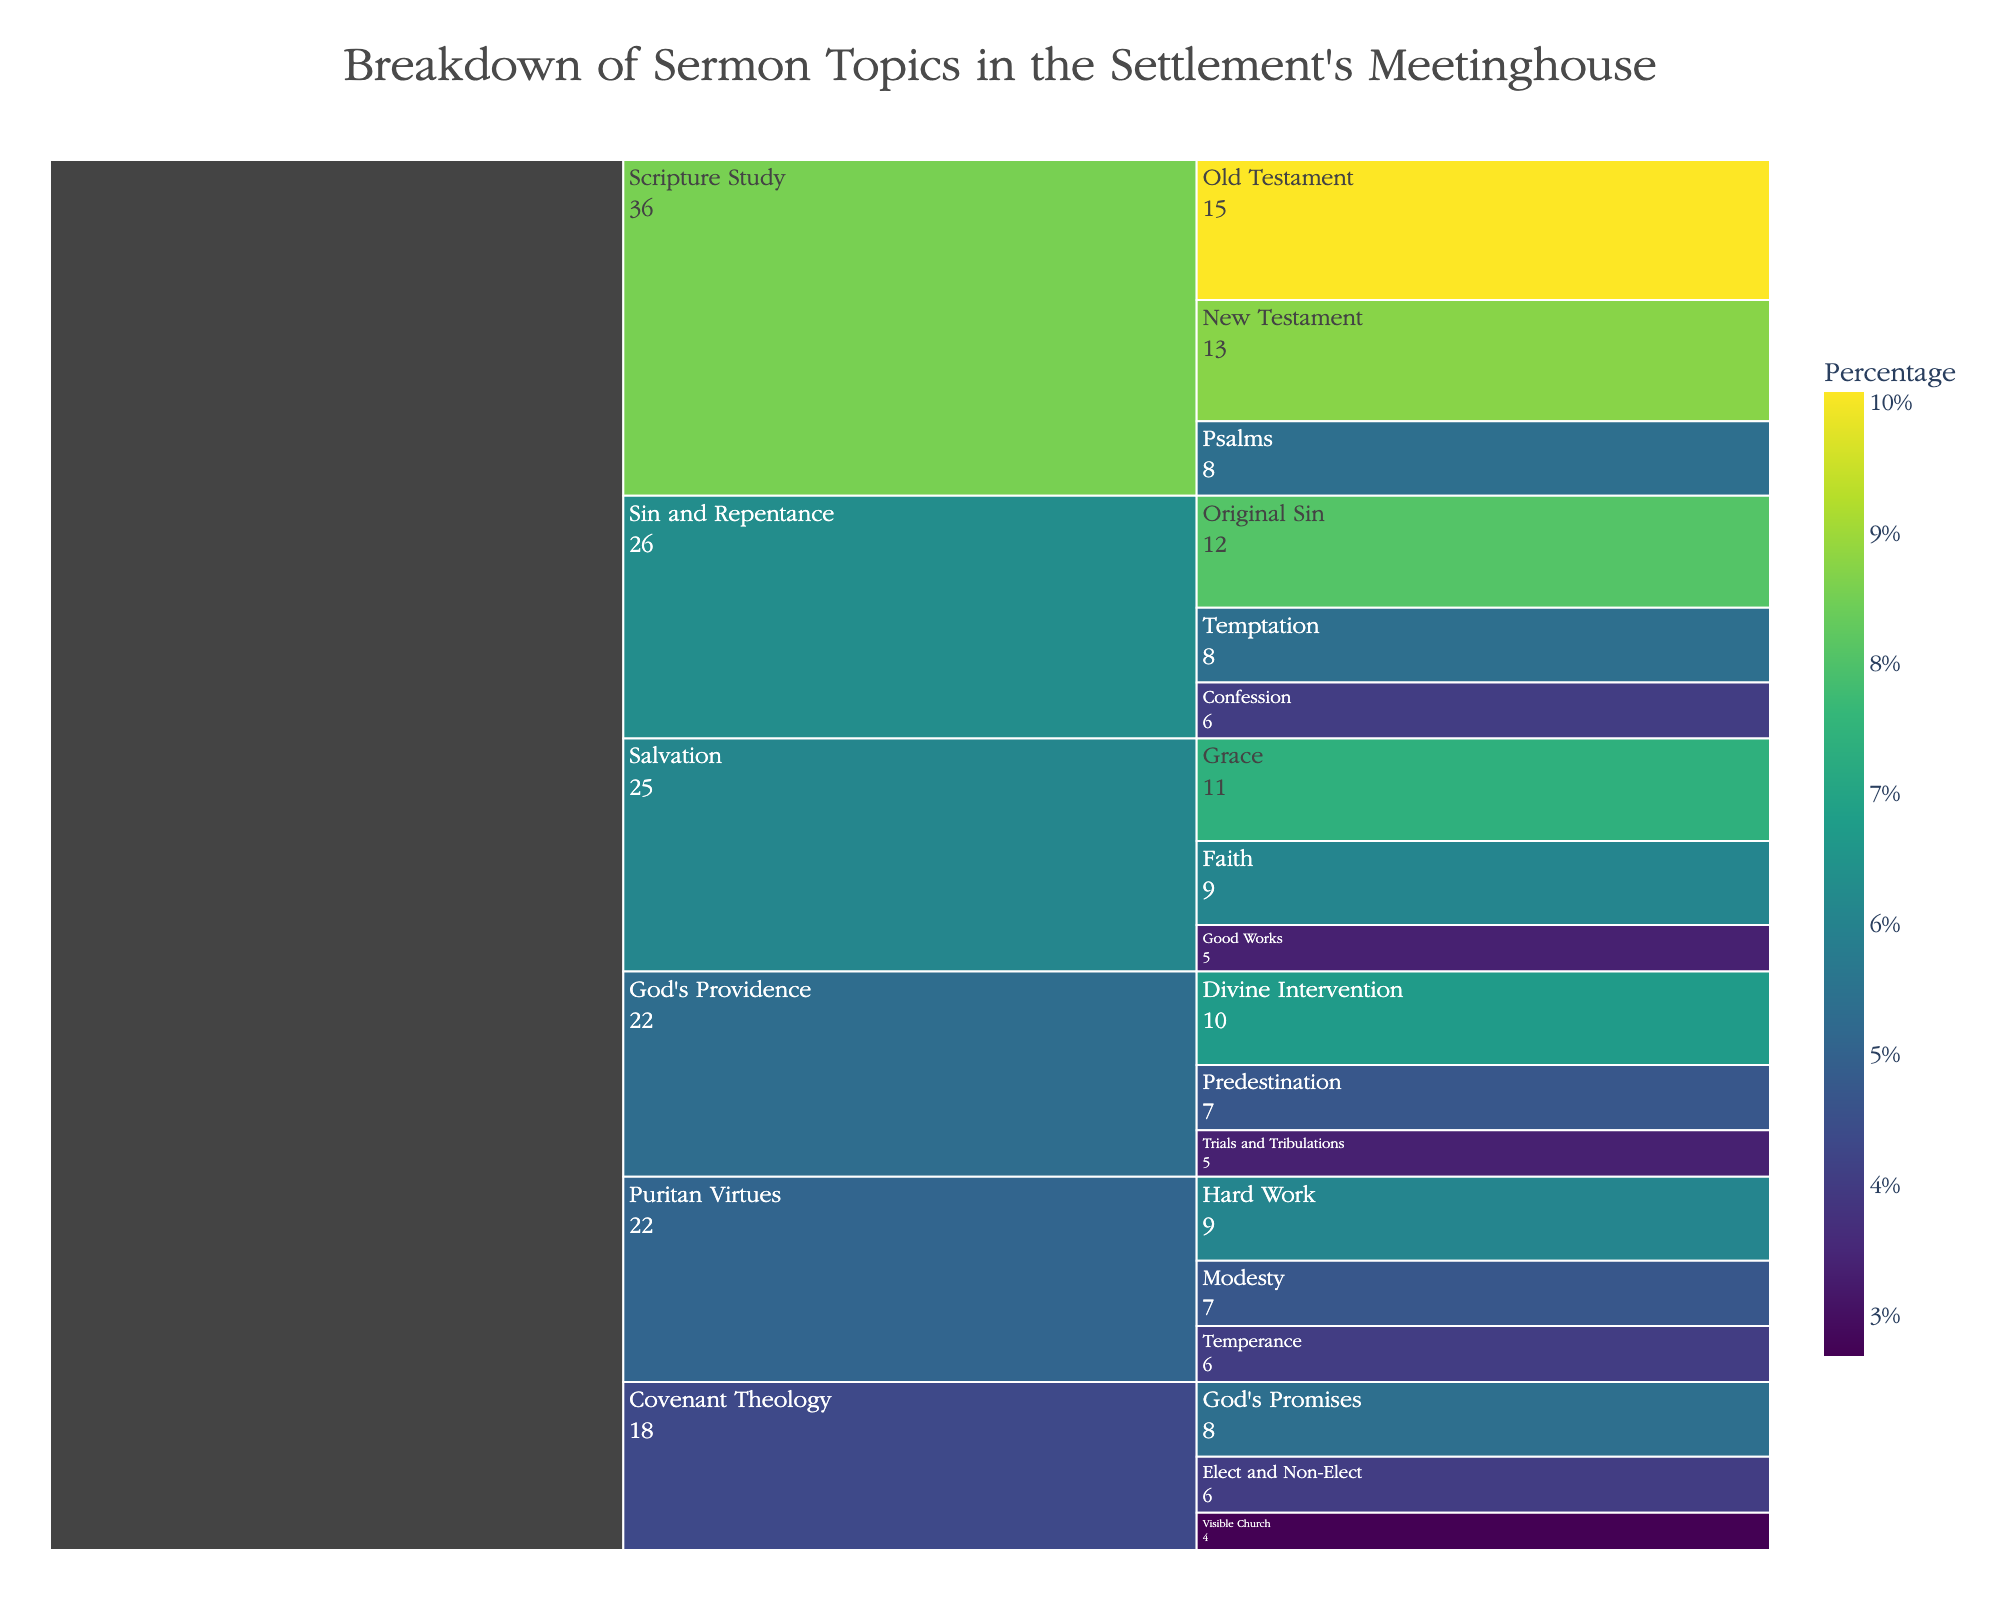What is the topic with the highest count of sermons? The figure's icicle chart shows the breakdown of sermon topics and subtopics, with the values indicated next to the labels. Identify the topic with the highest total count.
Answer: Scripture Study How many sermons were delivered on the subtopic of 'Grace'? Look for the subtopic 'Grace' in the icicle chart and note the count value next to it.
Answer: 11 What's the combined count of sermons under 'Puritan Virtues'? Add up the sermon counts for the three subtopics under 'Puritan Virtues' (Hard Work, Modesty, Temperance). 9 + 7 + 6 = 22
Answer: 22 Which subtopic under 'God's Providence' has the lowest count? Identify the three subtopics under 'God's Providence' in the icicle chart and compare their counts to find the lowest one.
Answer: Trials and Tribulations Is the count of sermons on 'Sin and Repentance' more than that on 'Salvation'? Compare the total sermon count under 'Sin and Repentance' (12 + 8 + 6) and 'Salvation' (11 + 9 + 5). 26 > 25
Answer: Yes Which subtopic has the exact same count as 'Faith' under 'Salvation'? Look for 'Faith' within 'Salvation' (with count 9), and identify other subtopics with the same count. 'Hard Work' (under Puritan Virtues) also has a count of 9.
Answer: Hard Work What percentage of the total sermons is on 'Old Testament'? The icicle chart includes a color scale indicating the percentage, and hover data might show it too. If not, divide the count for 'Old Testament' by the sum of all counts and multiply by 100. (15 / 144) * 100 ≈ 10.42%
Answer: 10.4% Which topic has the least representation from its subtopics in terms of sermon count? Compare the total counts of all main topics to identify the one with the lowest sum. Add up all subtopic counts for each main topic and find the smallest total. Covenant Theology (8 + 6 + 4 = 18) is the lowest.
Answer: Covenant Theology Which subtopics have a count greater than 10? Identify subtopics with counts larger than 10 in the icicle chart. 'Old Testament' with 15, 'New Testament' with 13, and 'Grace' with 11.
Answer: Old Testament, New Testament, Grace 